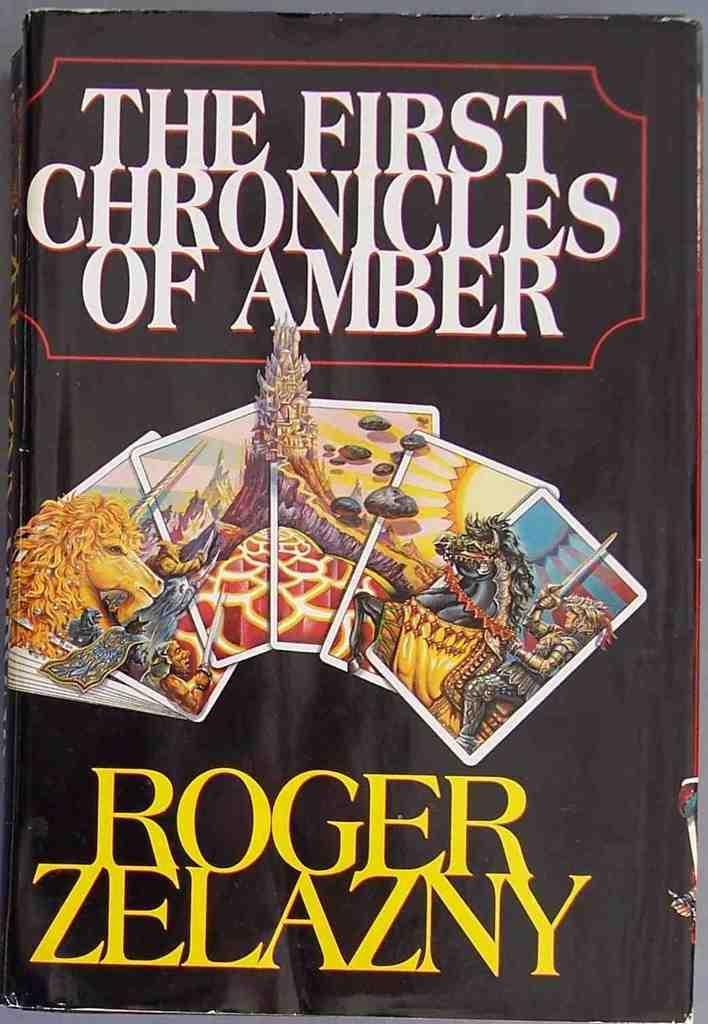Provide a one-sentence caption for the provided image. The book "The First Chronicles of Amber" by Roger Zelazny. 